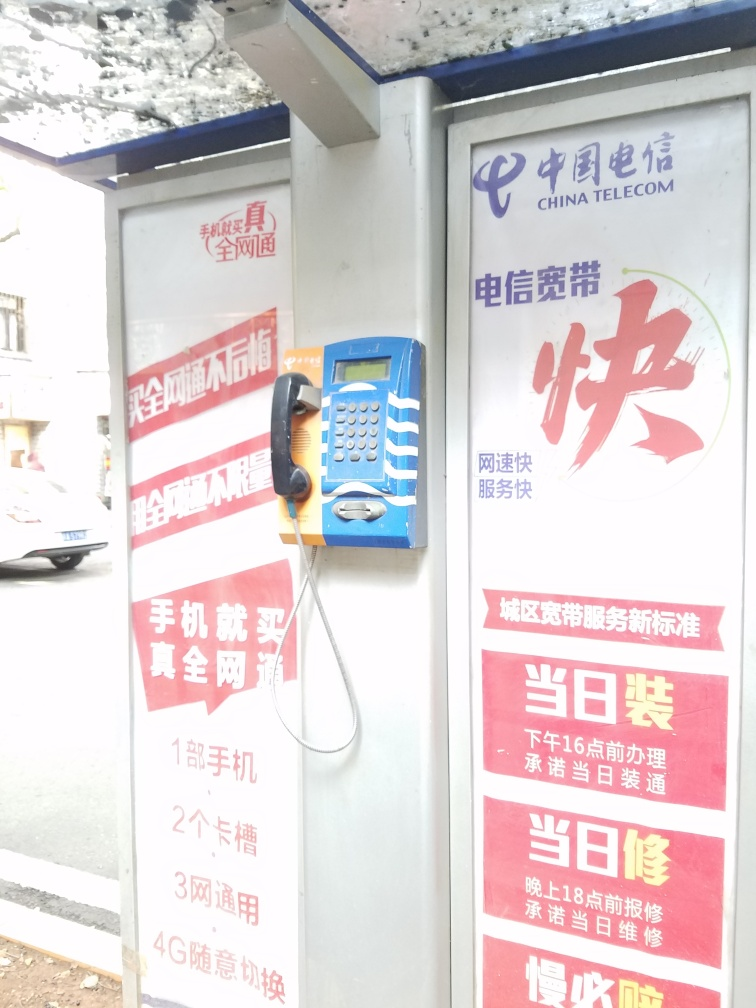Can you describe what the image shows? This image captures an outdoor public telephone booth operated by China Telecom. The booth has prominent advertising and informational posters in red and white, some detailing service plans. The booth is a familiar sight in many areas, providing a means of public communication, especially in regions with limited cell service or for those without a mobile phone. 